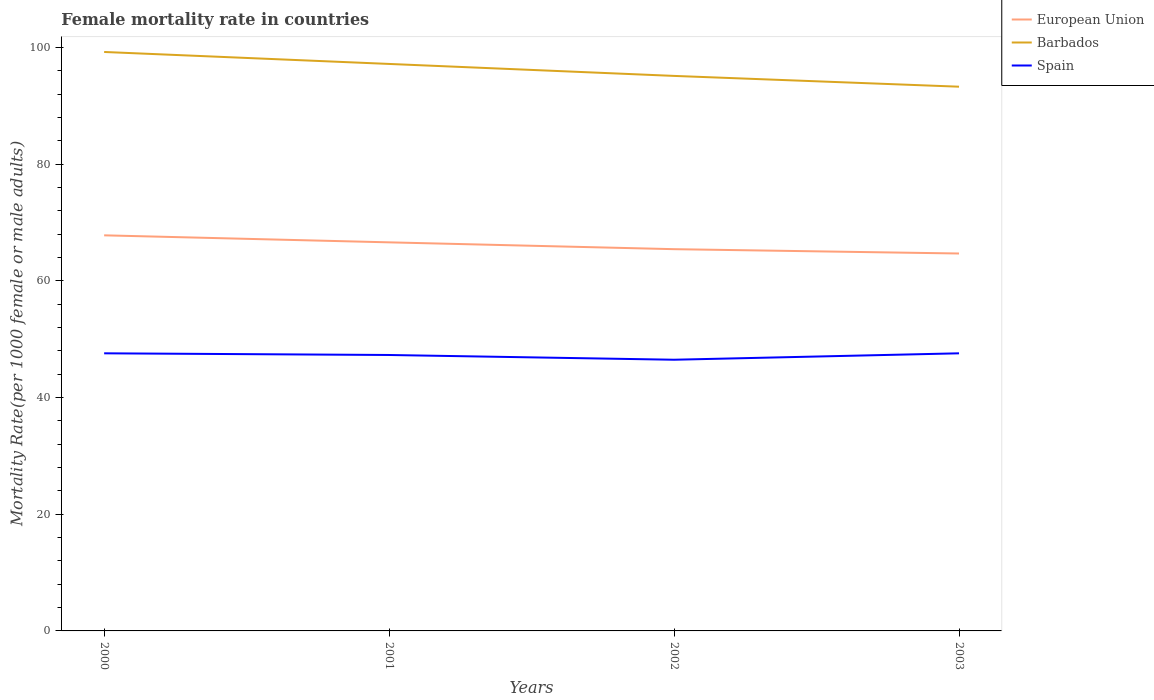How many different coloured lines are there?
Provide a short and direct response. 3. Does the line corresponding to Spain intersect with the line corresponding to European Union?
Offer a very short reply. No. Is the number of lines equal to the number of legend labels?
Make the answer very short. Yes. Across all years, what is the maximum female mortality rate in European Union?
Offer a terse response. 64.68. What is the total female mortality rate in Spain in the graph?
Offer a terse response. 0.29. What is the difference between the highest and the second highest female mortality rate in Spain?
Offer a terse response. 1.1. Is the female mortality rate in Spain strictly greater than the female mortality rate in European Union over the years?
Your answer should be compact. Yes. How many years are there in the graph?
Provide a short and direct response. 4. Are the values on the major ticks of Y-axis written in scientific E-notation?
Provide a succinct answer. No. Does the graph contain any zero values?
Make the answer very short. No. Does the graph contain grids?
Make the answer very short. No. How many legend labels are there?
Keep it short and to the point. 3. How are the legend labels stacked?
Give a very brief answer. Vertical. What is the title of the graph?
Offer a terse response. Female mortality rate in countries. What is the label or title of the Y-axis?
Your answer should be very brief. Mortality Rate(per 1000 female or male adults). What is the Mortality Rate(per 1000 female or male adults) of European Union in 2000?
Ensure brevity in your answer.  67.79. What is the Mortality Rate(per 1000 female or male adults) in Barbados in 2000?
Your response must be concise. 99.22. What is the Mortality Rate(per 1000 female or male adults) in Spain in 2000?
Give a very brief answer. 47.57. What is the Mortality Rate(per 1000 female or male adults) in European Union in 2001?
Provide a succinct answer. 66.59. What is the Mortality Rate(per 1000 female or male adults) in Barbados in 2001?
Provide a succinct answer. 97.16. What is the Mortality Rate(per 1000 female or male adults) of Spain in 2001?
Ensure brevity in your answer.  47.29. What is the Mortality Rate(per 1000 female or male adults) of European Union in 2002?
Ensure brevity in your answer.  65.42. What is the Mortality Rate(per 1000 female or male adults) of Barbados in 2002?
Provide a short and direct response. 95.11. What is the Mortality Rate(per 1000 female or male adults) in Spain in 2002?
Provide a succinct answer. 46.47. What is the Mortality Rate(per 1000 female or male adults) in European Union in 2003?
Make the answer very short. 64.68. What is the Mortality Rate(per 1000 female or male adults) in Barbados in 2003?
Your answer should be very brief. 93.26. What is the Mortality Rate(per 1000 female or male adults) of Spain in 2003?
Offer a very short reply. 47.57. Across all years, what is the maximum Mortality Rate(per 1000 female or male adults) of European Union?
Offer a terse response. 67.79. Across all years, what is the maximum Mortality Rate(per 1000 female or male adults) in Barbados?
Your response must be concise. 99.22. Across all years, what is the maximum Mortality Rate(per 1000 female or male adults) in Spain?
Provide a short and direct response. 47.57. Across all years, what is the minimum Mortality Rate(per 1000 female or male adults) in European Union?
Your answer should be very brief. 64.68. Across all years, what is the minimum Mortality Rate(per 1000 female or male adults) of Barbados?
Offer a terse response. 93.26. Across all years, what is the minimum Mortality Rate(per 1000 female or male adults) in Spain?
Make the answer very short. 46.47. What is the total Mortality Rate(per 1000 female or male adults) in European Union in the graph?
Make the answer very short. 264.48. What is the total Mortality Rate(per 1000 female or male adults) of Barbados in the graph?
Your answer should be very brief. 384.76. What is the total Mortality Rate(per 1000 female or male adults) in Spain in the graph?
Keep it short and to the point. 188.91. What is the difference between the Mortality Rate(per 1000 female or male adults) of European Union in 2000 and that in 2001?
Ensure brevity in your answer.  1.2. What is the difference between the Mortality Rate(per 1000 female or male adults) of Barbados in 2000 and that in 2001?
Your answer should be very brief. 2.05. What is the difference between the Mortality Rate(per 1000 female or male adults) in Spain in 2000 and that in 2001?
Your answer should be compact. 0.29. What is the difference between the Mortality Rate(per 1000 female or male adults) of European Union in 2000 and that in 2002?
Provide a succinct answer. 2.37. What is the difference between the Mortality Rate(per 1000 female or male adults) in Barbados in 2000 and that in 2002?
Make the answer very short. 4.1. What is the difference between the Mortality Rate(per 1000 female or male adults) in Spain in 2000 and that in 2002?
Your answer should be very brief. 1.1. What is the difference between the Mortality Rate(per 1000 female or male adults) in European Union in 2000 and that in 2003?
Give a very brief answer. 3.12. What is the difference between the Mortality Rate(per 1000 female or male adults) of Barbados in 2000 and that in 2003?
Give a very brief answer. 5.95. What is the difference between the Mortality Rate(per 1000 female or male adults) in Spain in 2000 and that in 2003?
Ensure brevity in your answer.  0. What is the difference between the Mortality Rate(per 1000 female or male adults) of European Union in 2001 and that in 2002?
Your response must be concise. 1.17. What is the difference between the Mortality Rate(per 1000 female or male adults) of Barbados in 2001 and that in 2002?
Provide a short and direct response. 2.05. What is the difference between the Mortality Rate(per 1000 female or male adults) of Spain in 2001 and that in 2002?
Your response must be concise. 0.81. What is the difference between the Mortality Rate(per 1000 female or male adults) in European Union in 2001 and that in 2003?
Provide a succinct answer. 1.91. What is the difference between the Mortality Rate(per 1000 female or male adults) of Barbados in 2001 and that in 2003?
Keep it short and to the point. 3.9. What is the difference between the Mortality Rate(per 1000 female or male adults) of Spain in 2001 and that in 2003?
Your answer should be compact. -0.29. What is the difference between the Mortality Rate(per 1000 female or male adults) in European Union in 2002 and that in 2003?
Your response must be concise. 0.74. What is the difference between the Mortality Rate(per 1000 female or male adults) of Barbados in 2002 and that in 2003?
Offer a terse response. 1.85. What is the difference between the Mortality Rate(per 1000 female or male adults) in Spain in 2002 and that in 2003?
Ensure brevity in your answer.  -1.1. What is the difference between the Mortality Rate(per 1000 female or male adults) of European Union in 2000 and the Mortality Rate(per 1000 female or male adults) of Barbados in 2001?
Ensure brevity in your answer.  -29.37. What is the difference between the Mortality Rate(per 1000 female or male adults) of European Union in 2000 and the Mortality Rate(per 1000 female or male adults) of Spain in 2001?
Provide a short and direct response. 20.51. What is the difference between the Mortality Rate(per 1000 female or male adults) in Barbados in 2000 and the Mortality Rate(per 1000 female or male adults) in Spain in 2001?
Offer a very short reply. 51.93. What is the difference between the Mortality Rate(per 1000 female or male adults) of European Union in 2000 and the Mortality Rate(per 1000 female or male adults) of Barbados in 2002?
Your answer should be compact. -27.32. What is the difference between the Mortality Rate(per 1000 female or male adults) of European Union in 2000 and the Mortality Rate(per 1000 female or male adults) of Spain in 2002?
Provide a short and direct response. 21.32. What is the difference between the Mortality Rate(per 1000 female or male adults) of Barbados in 2000 and the Mortality Rate(per 1000 female or male adults) of Spain in 2002?
Ensure brevity in your answer.  52.74. What is the difference between the Mortality Rate(per 1000 female or male adults) of European Union in 2000 and the Mortality Rate(per 1000 female or male adults) of Barbados in 2003?
Your answer should be compact. -25.47. What is the difference between the Mortality Rate(per 1000 female or male adults) in European Union in 2000 and the Mortality Rate(per 1000 female or male adults) in Spain in 2003?
Provide a succinct answer. 20.22. What is the difference between the Mortality Rate(per 1000 female or male adults) of Barbados in 2000 and the Mortality Rate(per 1000 female or male adults) of Spain in 2003?
Provide a short and direct response. 51.64. What is the difference between the Mortality Rate(per 1000 female or male adults) in European Union in 2001 and the Mortality Rate(per 1000 female or male adults) in Barbados in 2002?
Provide a succinct answer. -28.52. What is the difference between the Mortality Rate(per 1000 female or male adults) of European Union in 2001 and the Mortality Rate(per 1000 female or male adults) of Spain in 2002?
Your response must be concise. 20.12. What is the difference between the Mortality Rate(per 1000 female or male adults) of Barbados in 2001 and the Mortality Rate(per 1000 female or male adults) of Spain in 2002?
Give a very brief answer. 50.69. What is the difference between the Mortality Rate(per 1000 female or male adults) of European Union in 2001 and the Mortality Rate(per 1000 female or male adults) of Barbados in 2003?
Offer a very short reply. -26.67. What is the difference between the Mortality Rate(per 1000 female or male adults) of European Union in 2001 and the Mortality Rate(per 1000 female or male adults) of Spain in 2003?
Make the answer very short. 19.02. What is the difference between the Mortality Rate(per 1000 female or male adults) in Barbados in 2001 and the Mortality Rate(per 1000 female or male adults) in Spain in 2003?
Offer a terse response. 49.59. What is the difference between the Mortality Rate(per 1000 female or male adults) in European Union in 2002 and the Mortality Rate(per 1000 female or male adults) in Barbados in 2003?
Provide a succinct answer. -27.84. What is the difference between the Mortality Rate(per 1000 female or male adults) of European Union in 2002 and the Mortality Rate(per 1000 female or male adults) of Spain in 2003?
Your answer should be very brief. 17.85. What is the difference between the Mortality Rate(per 1000 female or male adults) of Barbados in 2002 and the Mortality Rate(per 1000 female or male adults) of Spain in 2003?
Offer a terse response. 47.54. What is the average Mortality Rate(per 1000 female or male adults) of European Union per year?
Offer a very short reply. 66.12. What is the average Mortality Rate(per 1000 female or male adults) of Barbados per year?
Make the answer very short. 96.19. What is the average Mortality Rate(per 1000 female or male adults) of Spain per year?
Ensure brevity in your answer.  47.23. In the year 2000, what is the difference between the Mortality Rate(per 1000 female or male adults) in European Union and Mortality Rate(per 1000 female or male adults) in Barbados?
Give a very brief answer. -31.42. In the year 2000, what is the difference between the Mortality Rate(per 1000 female or male adults) in European Union and Mortality Rate(per 1000 female or male adults) in Spain?
Keep it short and to the point. 20.22. In the year 2000, what is the difference between the Mortality Rate(per 1000 female or male adults) of Barbados and Mortality Rate(per 1000 female or male adults) of Spain?
Keep it short and to the point. 51.64. In the year 2001, what is the difference between the Mortality Rate(per 1000 female or male adults) of European Union and Mortality Rate(per 1000 female or male adults) of Barbados?
Offer a terse response. -30.57. In the year 2001, what is the difference between the Mortality Rate(per 1000 female or male adults) in European Union and Mortality Rate(per 1000 female or male adults) in Spain?
Offer a very short reply. 19.31. In the year 2001, what is the difference between the Mortality Rate(per 1000 female or male adults) in Barbados and Mortality Rate(per 1000 female or male adults) in Spain?
Provide a succinct answer. 49.88. In the year 2002, what is the difference between the Mortality Rate(per 1000 female or male adults) in European Union and Mortality Rate(per 1000 female or male adults) in Barbados?
Provide a short and direct response. -29.69. In the year 2002, what is the difference between the Mortality Rate(per 1000 female or male adults) in European Union and Mortality Rate(per 1000 female or male adults) in Spain?
Keep it short and to the point. 18.95. In the year 2002, what is the difference between the Mortality Rate(per 1000 female or male adults) in Barbados and Mortality Rate(per 1000 female or male adults) in Spain?
Your answer should be very brief. 48.64. In the year 2003, what is the difference between the Mortality Rate(per 1000 female or male adults) in European Union and Mortality Rate(per 1000 female or male adults) in Barbados?
Make the answer very short. -28.59. In the year 2003, what is the difference between the Mortality Rate(per 1000 female or male adults) in European Union and Mortality Rate(per 1000 female or male adults) in Spain?
Offer a terse response. 17.1. In the year 2003, what is the difference between the Mortality Rate(per 1000 female or male adults) of Barbados and Mortality Rate(per 1000 female or male adults) of Spain?
Your answer should be compact. 45.69. What is the ratio of the Mortality Rate(per 1000 female or male adults) of European Union in 2000 to that in 2001?
Offer a very short reply. 1.02. What is the ratio of the Mortality Rate(per 1000 female or male adults) of Barbados in 2000 to that in 2001?
Provide a succinct answer. 1.02. What is the ratio of the Mortality Rate(per 1000 female or male adults) in European Union in 2000 to that in 2002?
Provide a succinct answer. 1.04. What is the ratio of the Mortality Rate(per 1000 female or male adults) of Barbados in 2000 to that in 2002?
Make the answer very short. 1.04. What is the ratio of the Mortality Rate(per 1000 female or male adults) of Spain in 2000 to that in 2002?
Ensure brevity in your answer.  1.02. What is the ratio of the Mortality Rate(per 1000 female or male adults) of European Union in 2000 to that in 2003?
Provide a succinct answer. 1.05. What is the ratio of the Mortality Rate(per 1000 female or male adults) in Barbados in 2000 to that in 2003?
Your answer should be very brief. 1.06. What is the ratio of the Mortality Rate(per 1000 female or male adults) of European Union in 2001 to that in 2002?
Offer a very short reply. 1.02. What is the ratio of the Mortality Rate(per 1000 female or male adults) of Barbados in 2001 to that in 2002?
Make the answer very short. 1.02. What is the ratio of the Mortality Rate(per 1000 female or male adults) in Spain in 2001 to that in 2002?
Your answer should be compact. 1.02. What is the ratio of the Mortality Rate(per 1000 female or male adults) of European Union in 2001 to that in 2003?
Provide a short and direct response. 1.03. What is the ratio of the Mortality Rate(per 1000 female or male adults) in Barbados in 2001 to that in 2003?
Offer a terse response. 1.04. What is the ratio of the Mortality Rate(per 1000 female or male adults) of Spain in 2001 to that in 2003?
Provide a short and direct response. 0.99. What is the ratio of the Mortality Rate(per 1000 female or male adults) of European Union in 2002 to that in 2003?
Keep it short and to the point. 1.01. What is the ratio of the Mortality Rate(per 1000 female or male adults) in Barbados in 2002 to that in 2003?
Keep it short and to the point. 1.02. What is the ratio of the Mortality Rate(per 1000 female or male adults) in Spain in 2002 to that in 2003?
Your answer should be compact. 0.98. What is the difference between the highest and the second highest Mortality Rate(per 1000 female or male adults) of European Union?
Provide a succinct answer. 1.2. What is the difference between the highest and the second highest Mortality Rate(per 1000 female or male adults) in Barbados?
Your answer should be compact. 2.05. What is the difference between the highest and the second highest Mortality Rate(per 1000 female or male adults) of Spain?
Offer a terse response. 0. What is the difference between the highest and the lowest Mortality Rate(per 1000 female or male adults) in European Union?
Give a very brief answer. 3.12. What is the difference between the highest and the lowest Mortality Rate(per 1000 female or male adults) of Barbados?
Your answer should be compact. 5.95. What is the difference between the highest and the lowest Mortality Rate(per 1000 female or male adults) of Spain?
Your answer should be very brief. 1.1. 